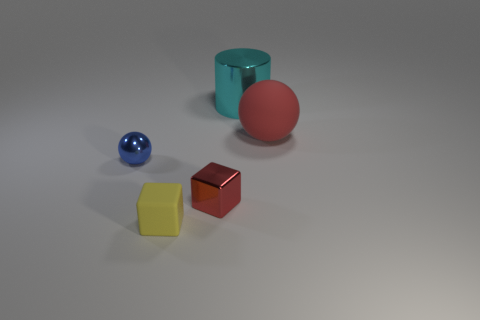Add 1 large cyan things. How many objects exist? 6 Subtract all red blocks. How many blocks are left? 1 Subtract all spheres. How many objects are left? 3 Subtract 2 balls. How many balls are left? 0 Add 2 large cyan metal objects. How many large cyan metal objects are left? 3 Add 1 cyan cylinders. How many cyan cylinders exist? 2 Subtract 0 gray balls. How many objects are left? 5 Subtract all cyan balls. Subtract all gray blocks. How many balls are left? 2 Subtract all red cylinders. How many gray blocks are left? 0 Subtract all cubes. Subtract all tiny objects. How many objects are left? 0 